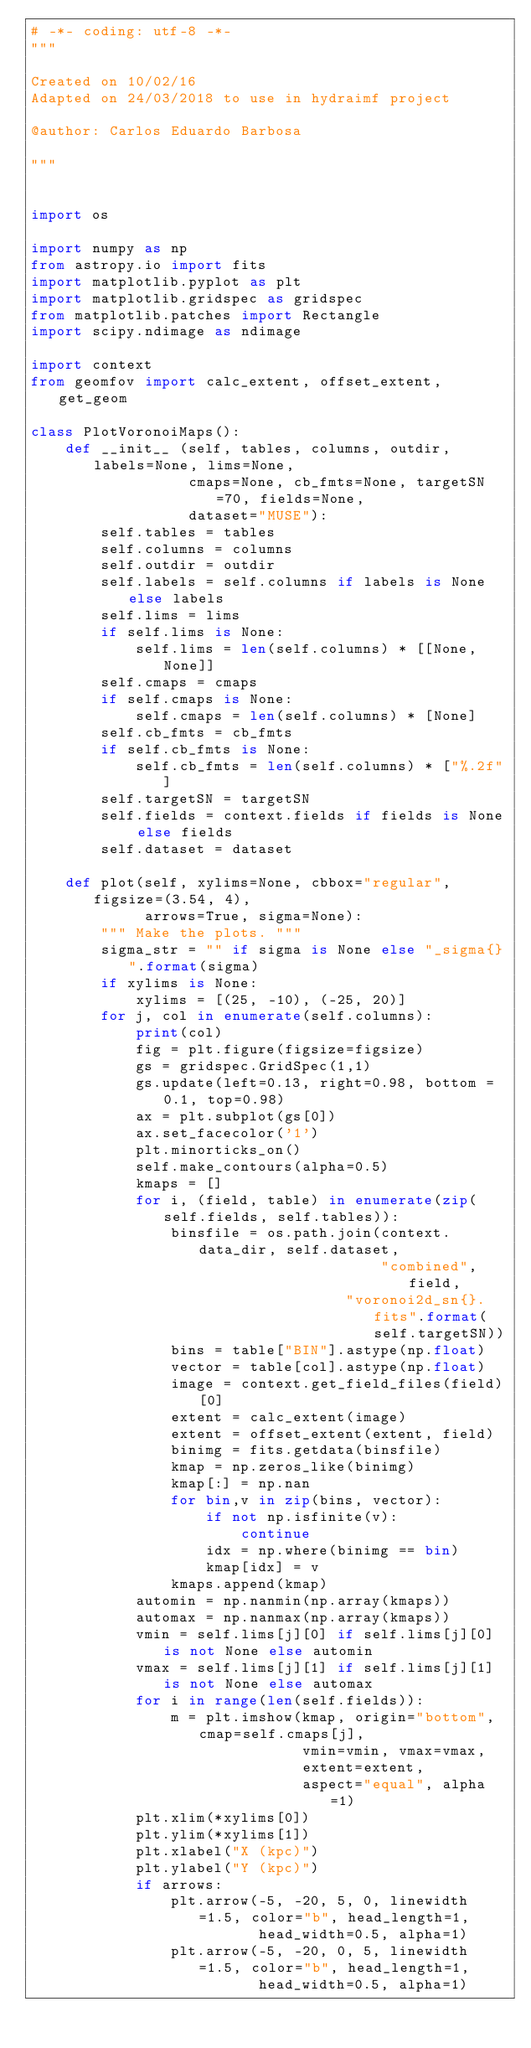<code> <loc_0><loc_0><loc_500><loc_500><_Python_># -*- coding: utf-8 -*-
"""

Created on 10/02/16
Adapted on 24/03/2018 to use in hydraimf project

@author: Carlos Eduardo Barbosa

"""


import os

import numpy as np
from astropy.io import fits
import matplotlib.pyplot as plt
import matplotlib.gridspec as gridspec
from matplotlib.patches import Rectangle
import scipy.ndimage as ndimage

import context
from geomfov import calc_extent, offset_extent, get_geom

class PlotVoronoiMaps():
    def __init__ (self, tables, columns, outdir, labels=None, lims=None,
                  cmaps=None, cb_fmts=None, targetSN=70, fields=None,
                  dataset="MUSE"):
        self.tables = tables
        self.columns = columns
        self.outdir = outdir
        self.labels = self.columns if labels is None else labels
        self.lims = lims
        if self.lims is None:
            self.lims = len(self.columns) * [[None, None]]
        self.cmaps = cmaps
        if self.cmaps is None:
            self.cmaps = len(self.columns) * [None]
        self.cb_fmts = cb_fmts
        if self.cb_fmts is None:
            self.cb_fmts = len(self.columns) * ["%.2f"]
        self.targetSN = targetSN
        self.fields = context.fields if fields is None else fields
        self.dataset = dataset

    def plot(self, xylims=None, cbbox="regular", figsize=(3.54, 4),
             arrows=True, sigma=None):
        """ Make the plots. """
        sigma_str = "" if sigma is None else "_sigma{}".format(sigma)
        if xylims is None:
            xylims = [(25, -10), (-25, 20)]
        for j, col in enumerate(self.columns):
            print(col)
            fig = plt.figure(figsize=figsize)
            gs = gridspec.GridSpec(1,1)
            gs.update(left=0.13, right=0.98, bottom = 0.1, top=0.98)
            ax = plt.subplot(gs[0])
            ax.set_facecolor('1')
            plt.minorticks_on()
            self.make_contours(alpha=0.5)
            kmaps = []
            for i, (field, table) in enumerate(zip(self.fields, self.tables)):
                binsfile = os.path.join(context.data_dir, self.dataset,
                                        "combined", field,
                                    "voronoi2d_sn{}.fits".format(self.targetSN))
                bins = table["BIN"].astype(np.float)
                vector = table[col].astype(np.float)
                image = context.get_field_files(field)[0]
                extent = calc_extent(image)
                extent = offset_extent(extent, field)
                binimg = fits.getdata(binsfile)
                kmap = np.zeros_like(binimg)
                kmap[:] = np.nan
                for bin,v in zip(bins, vector):
                    if not np.isfinite(v):
                        continue
                    idx = np.where(binimg == bin)
                    kmap[idx] = v
                kmaps.append(kmap)
            automin = np.nanmin(np.array(kmaps))
            automax = np.nanmax(np.array(kmaps))
            vmin = self.lims[j][0] if self.lims[j][0] is not None else automin
            vmax = self.lims[j][1] if self.lims[j][1] is not None else automax
            for i in range(len(self.fields)):
                m = plt.imshow(kmap, origin="bottom", cmap=self.cmaps[j],
                               vmin=vmin, vmax=vmax,
                               extent=extent,
                               aspect="equal", alpha=1)
            plt.xlim(*xylims[0])
            plt.ylim(*xylims[1])
            plt.xlabel("X (kpc)")
            plt.ylabel("Y (kpc)")
            if arrows:
                plt.arrow(-5, -20, 5, 0, linewidth=1.5, color="b", head_length=1,
                          head_width=0.5, alpha=1)
                plt.arrow(-5, -20, 0, 5, linewidth=1.5, color="b", head_length=1,
                          head_width=0.5, alpha=1)</code> 